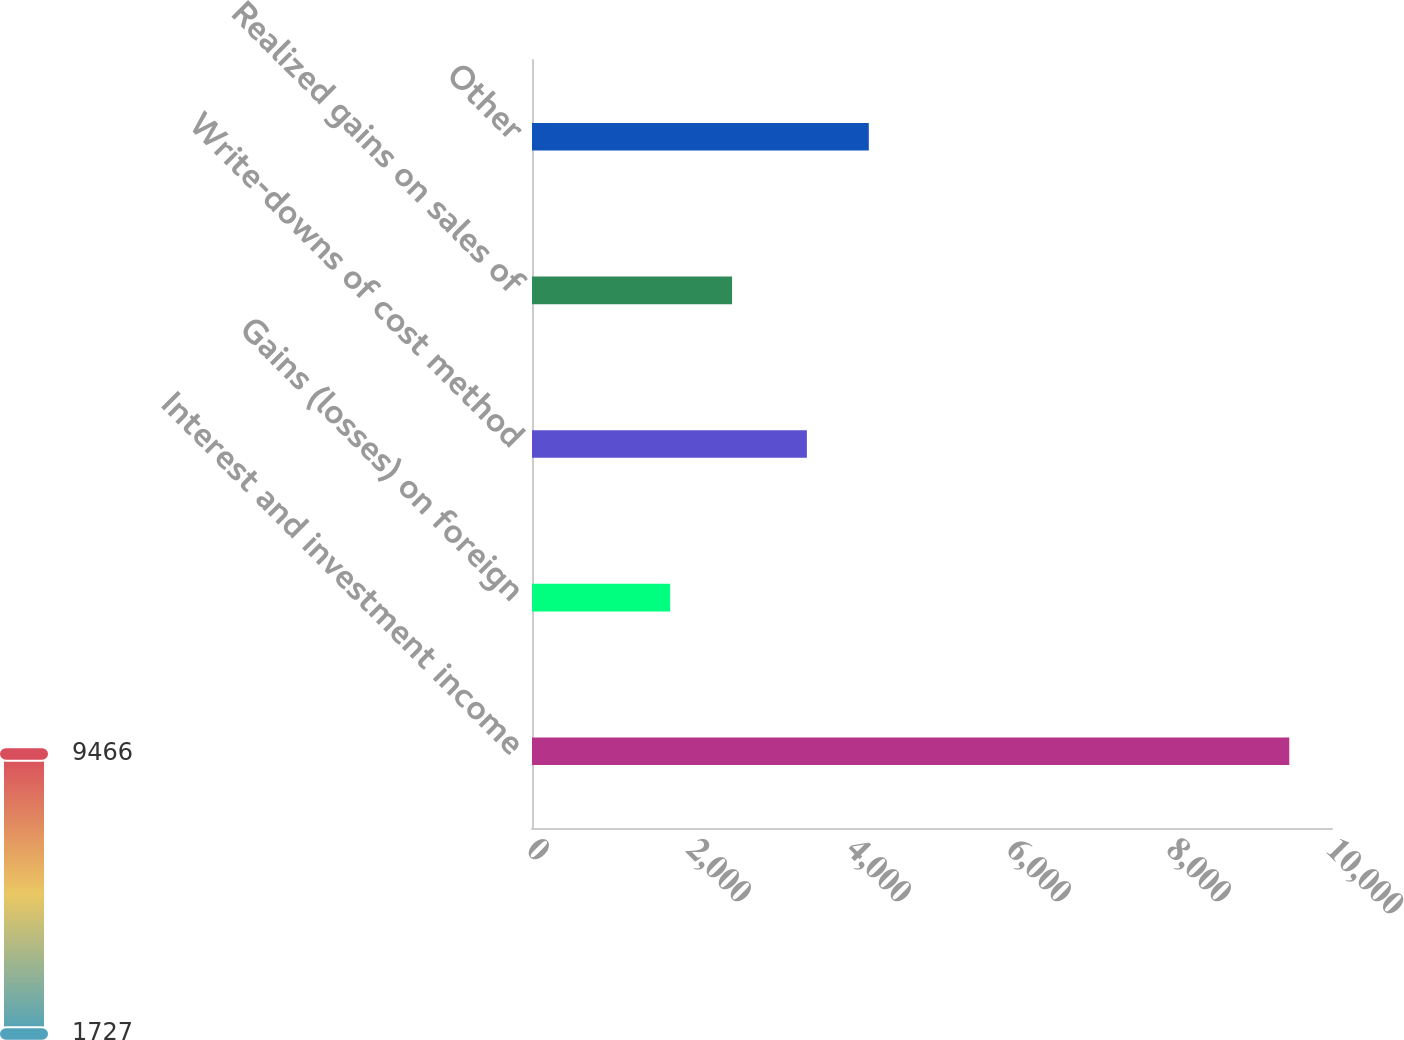Convert chart. <chart><loc_0><loc_0><loc_500><loc_500><bar_chart><fcel>Interest and investment income<fcel>Gains (losses) on foreign<fcel>Write-downs of cost method<fcel>Realized gains on sales of<fcel>Other<nl><fcel>9466<fcel>1727<fcel>3436<fcel>2500.9<fcel>4209.9<nl></chart> 